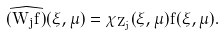Convert formula to latex. <formula><loc_0><loc_0><loc_500><loc_500>\widehat { ( W _ { j } f ) } ( \xi , \mu ) = \chi _ { Z _ { j } } ( \xi , \mu ) \hat { f } ( \xi , \mu ) .</formula> 